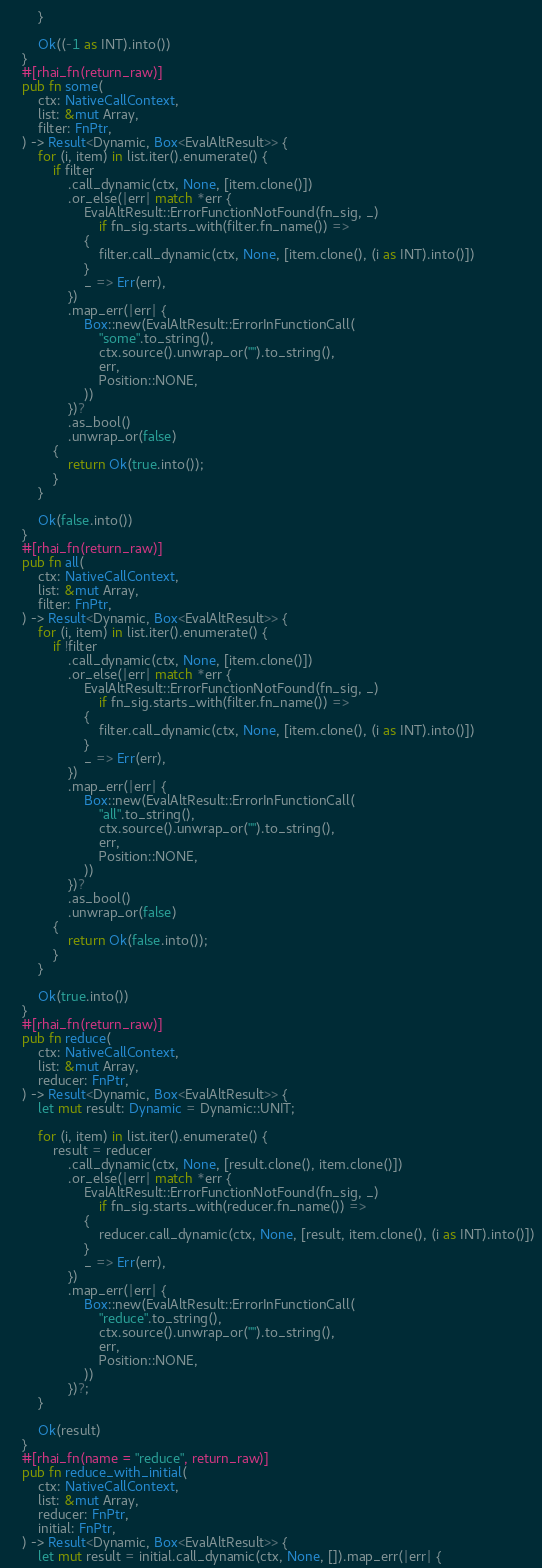<code> <loc_0><loc_0><loc_500><loc_500><_Rust_>        }

        Ok((-1 as INT).into())
    }
    #[rhai_fn(return_raw)]
    pub fn some(
        ctx: NativeCallContext,
        list: &mut Array,
        filter: FnPtr,
    ) -> Result<Dynamic, Box<EvalAltResult>> {
        for (i, item) in list.iter().enumerate() {
            if filter
                .call_dynamic(ctx, None, [item.clone()])
                .or_else(|err| match *err {
                    EvalAltResult::ErrorFunctionNotFound(fn_sig, _)
                        if fn_sig.starts_with(filter.fn_name()) =>
                    {
                        filter.call_dynamic(ctx, None, [item.clone(), (i as INT).into()])
                    }
                    _ => Err(err),
                })
                .map_err(|err| {
                    Box::new(EvalAltResult::ErrorInFunctionCall(
                        "some".to_string(),
                        ctx.source().unwrap_or("").to_string(),
                        err,
                        Position::NONE,
                    ))
                })?
                .as_bool()
                .unwrap_or(false)
            {
                return Ok(true.into());
            }
        }

        Ok(false.into())
    }
    #[rhai_fn(return_raw)]
    pub fn all(
        ctx: NativeCallContext,
        list: &mut Array,
        filter: FnPtr,
    ) -> Result<Dynamic, Box<EvalAltResult>> {
        for (i, item) in list.iter().enumerate() {
            if !filter
                .call_dynamic(ctx, None, [item.clone()])
                .or_else(|err| match *err {
                    EvalAltResult::ErrorFunctionNotFound(fn_sig, _)
                        if fn_sig.starts_with(filter.fn_name()) =>
                    {
                        filter.call_dynamic(ctx, None, [item.clone(), (i as INT).into()])
                    }
                    _ => Err(err),
                })
                .map_err(|err| {
                    Box::new(EvalAltResult::ErrorInFunctionCall(
                        "all".to_string(),
                        ctx.source().unwrap_or("").to_string(),
                        err,
                        Position::NONE,
                    ))
                })?
                .as_bool()
                .unwrap_or(false)
            {
                return Ok(false.into());
            }
        }

        Ok(true.into())
    }
    #[rhai_fn(return_raw)]
    pub fn reduce(
        ctx: NativeCallContext,
        list: &mut Array,
        reducer: FnPtr,
    ) -> Result<Dynamic, Box<EvalAltResult>> {
        let mut result: Dynamic = Dynamic::UNIT;

        for (i, item) in list.iter().enumerate() {
            result = reducer
                .call_dynamic(ctx, None, [result.clone(), item.clone()])
                .or_else(|err| match *err {
                    EvalAltResult::ErrorFunctionNotFound(fn_sig, _)
                        if fn_sig.starts_with(reducer.fn_name()) =>
                    {
                        reducer.call_dynamic(ctx, None, [result, item.clone(), (i as INT).into()])
                    }
                    _ => Err(err),
                })
                .map_err(|err| {
                    Box::new(EvalAltResult::ErrorInFunctionCall(
                        "reduce".to_string(),
                        ctx.source().unwrap_or("").to_string(),
                        err,
                        Position::NONE,
                    ))
                })?;
        }

        Ok(result)
    }
    #[rhai_fn(name = "reduce", return_raw)]
    pub fn reduce_with_initial(
        ctx: NativeCallContext,
        list: &mut Array,
        reducer: FnPtr,
        initial: FnPtr,
    ) -> Result<Dynamic, Box<EvalAltResult>> {
        let mut result = initial.call_dynamic(ctx, None, []).map_err(|err| {</code> 